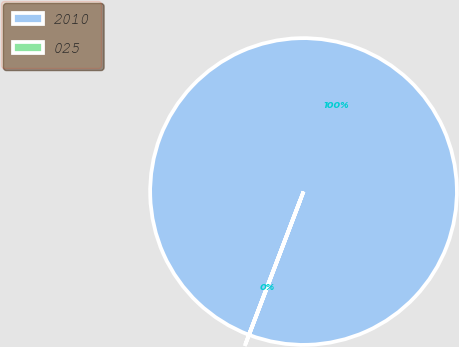<chart> <loc_0><loc_0><loc_500><loc_500><pie_chart><fcel>2010<fcel>025<nl><fcel>99.99%<fcel>0.01%<nl></chart> 